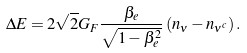<formula> <loc_0><loc_0><loc_500><loc_500>\Delta E = 2 \sqrt { 2 } G _ { F } \frac { \beta _ { e } } { \sqrt { 1 - \beta _ { e } ^ { 2 } } } \left ( n _ { \nu } - n _ { \nu ^ { c } } \right ) .</formula> 